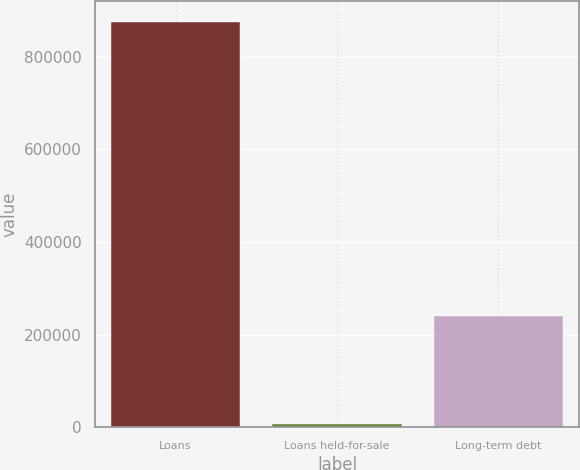<chart> <loc_0><loc_0><loc_500><loc_500><bar_chart><fcel>Loans<fcel>Loans held-for-sale<fcel>Long-term debt<nl><fcel>875594<fcel>7453<fcel>241109<nl></chart> 